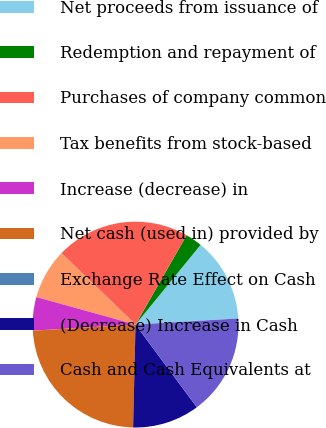<chart> <loc_0><loc_0><loc_500><loc_500><pie_chart><fcel>Net proceeds from issuance of<fcel>Redemption and repayment of<fcel>Purchases of company common<fcel>Tax benefits from stock-based<fcel>Increase (decrease) in<fcel>Net cash (used in) provided by<fcel>Exchange Rate Effect on Cash<fcel>(Decrease) Increase in Cash<fcel>Cash and Cash Equivalents at<nl><fcel>13.16%<fcel>2.63%<fcel>21.05%<fcel>7.9%<fcel>5.26%<fcel>23.68%<fcel>0.0%<fcel>10.53%<fcel>15.79%<nl></chart> 